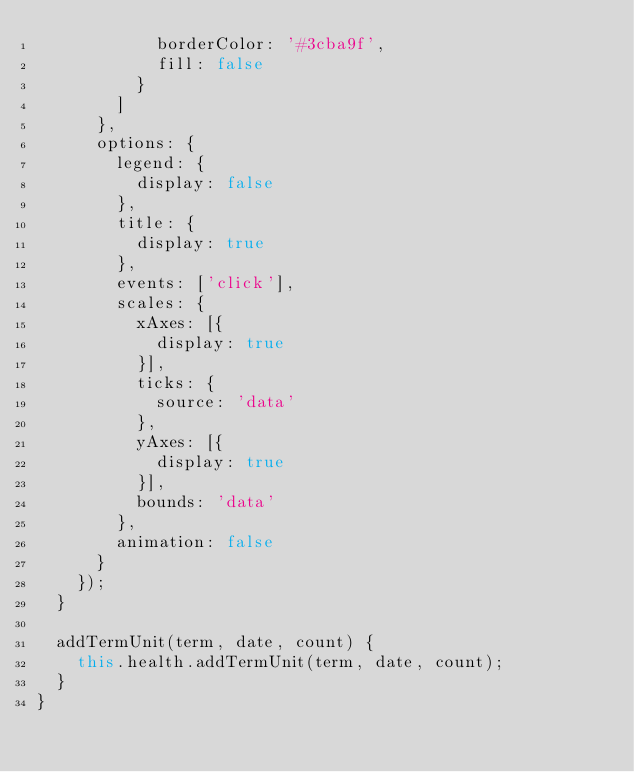Convert code to text. <code><loc_0><loc_0><loc_500><loc_500><_TypeScript_>            borderColor: '#3cba9f',
            fill: false
          }
        ]
      },
      options: {
        legend: {
          display: false
        },
        title: {
          display: true
        },
        events: ['click'],
        scales: {
          xAxes: [{
            display: true
          }],
          ticks: {
            source: 'data'
          },
          yAxes: [{
            display: true
          }],
          bounds: 'data'
        },
        animation: false
      }
    });
  }

  addTermUnit(term, date, count) {
    this.health.addTermUnit(term, date, count);
  }
}
</code> 